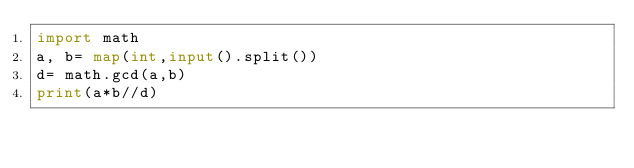<code> <loc_0><loc_0><loc_500><loc_500><_Python_>import math
a, b= map(int,input().split())
d= math.gcd(a,b)
print(a*b//d)
</code> 